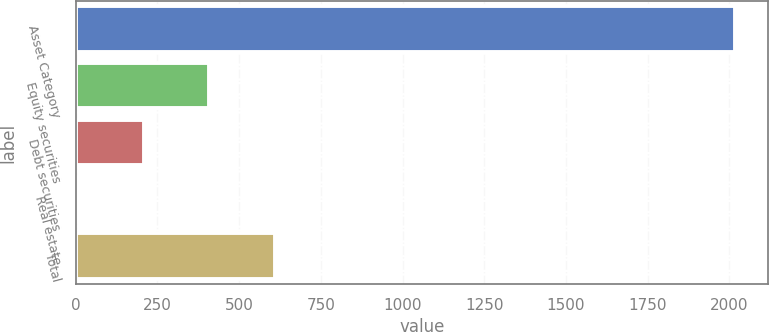Convert chart. <chart><loc_0><loc_0><loc_500><loc_500><bar_chart><fcel>Asset Category<fcel>Equity securities<fcel>Debt securities<fcel>Real estate<fcel>Total<nl><fcel>2017<fcel>409<fcel>208<fcel>7<fcel>610<nl></chart> 